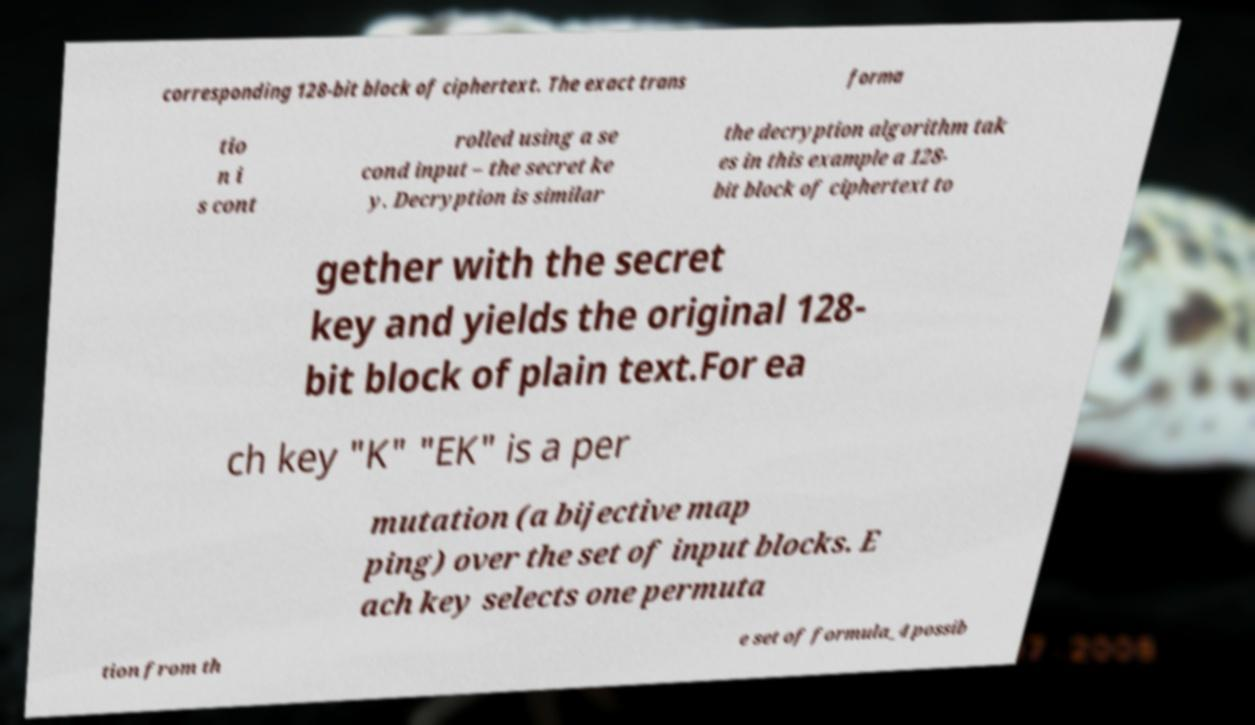What messages or text are displayed in this image? I need them in a readable, typed format. corresponding 128-bit block of ciphertext. The exact trans forma tio n i s cont rolled using a se cond input – the secret ke y. Decryption is similar the decryption algorithm tak es in this example a 128- bit block of ciphertext to gether with the secret key and yields the original 128- bit block of plain text.For ea ch key "K" "EK" is a per mutation (a bijective map ping) over the set of input blocks. E ach key selects one permuta tion from th e set of formula_4 possib 